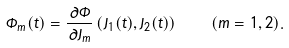<formula> <loc_0><loc_0><loc_500><loc_500>\Phi _ { m } ( t ) = \frac { \partial \Phi } { \partial J _ { m } } \left ( J _ { 1 } ( t ) , J _ { 2 } ( t ) \right ) \quad ( m = 1 , 2 ) .</formula> 